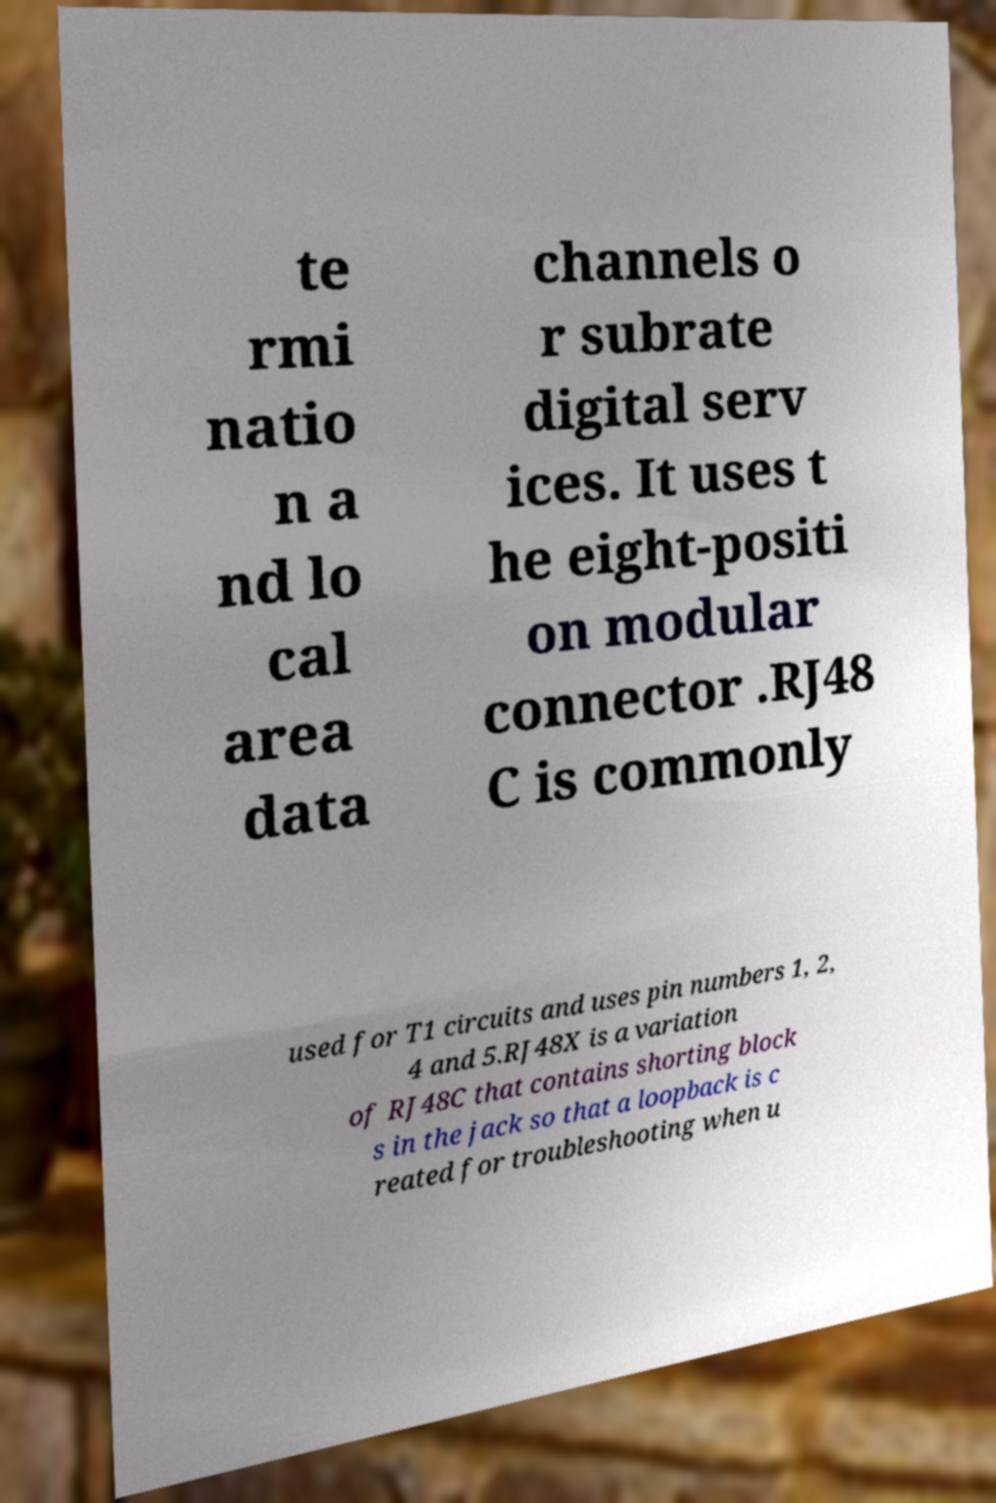What messages or text are displayed in this image? I need them in a readable, typed format. te rmi natio n a nd lo cal area data channels o r subrate digital serv ices. It uses t he eight-positi on modular connector .RJ48 C is commonly used for T1 circuits and uses pin numbers 1, 2, 4 and 5.RJ48X is a variation of RJ48C that contains shorting block s in the jack so that a loopback is c reated for troubleshooting when u 